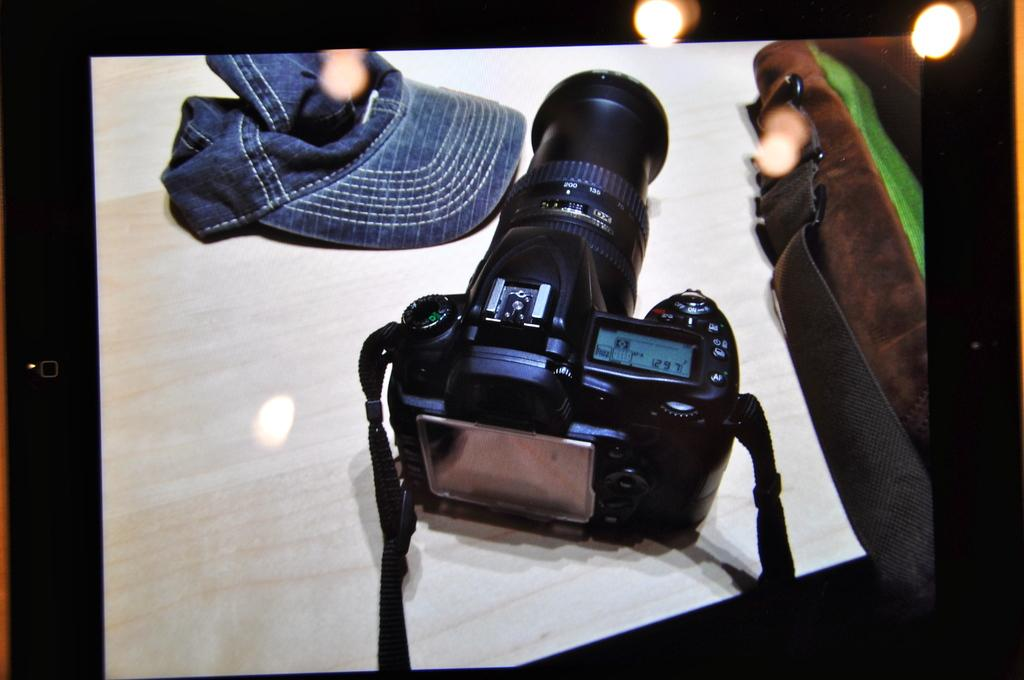What object is placed on the table in the image? There is a camera on the table. What other items can be seen on the table? There is a cap and a bag on the table. Can you describe the lighting in the image? Yes, there are lights visible in the image. How many houses are visible in the image? There are no houses visible in the image; it only shows objects on a table. Can you describe the worm crawling on the camera in the image? There is no worm present in the image; it only shows a camera, a cap, and a bag on a table. 